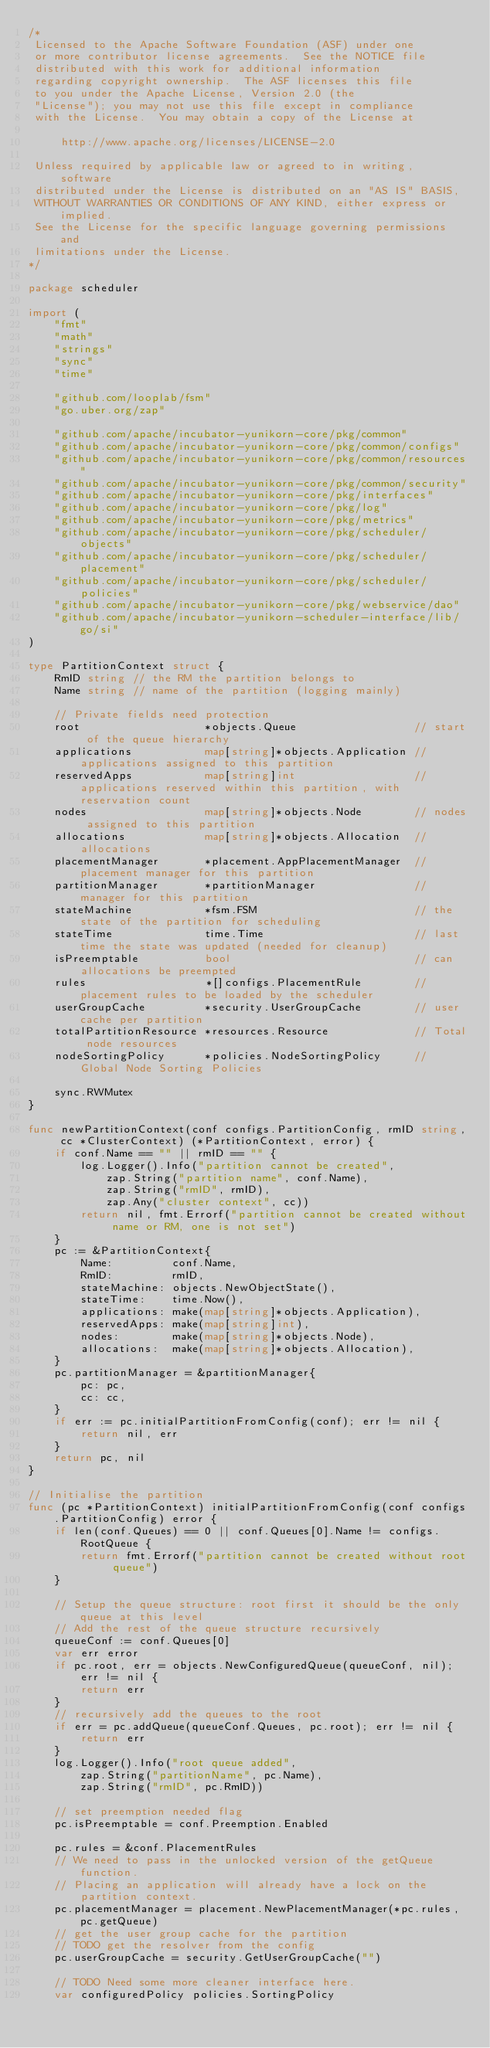Convert code to text. <code><loc_0><loc_0><loc_500><loc_500><_Go_>/*
 Licensed to the Apache Software Foundation (ASF) under one
 or more contributor license agreements.  See the NOTICE file
 distributed with this work for additional information
 regarding copyright ownership.  The ASF licenses this file
 to you under the Apache License, Version 2.0 (the
 "License"); you may not use this file except in compliance
 with the License.  You may obtain a copy of the License at

     http://www.apache.org/licenses/LICENSE-2.0

 Unless required by applicable law or agreed to in writing, software
 distributed under the License is distributed on an "AS IS" BASIS,
 WITHOUT WARRANTIES OR CONDITIONS OF ANY KIND, either express or implied.
 See the License for the specific language governing permissions and
 limitations under the License.
*/

package scheduler

import (
	"fmt"
	"math"
	"strings"
	"sync"
	"time"

	"github.com/looplab/fsm"
	"go.uber.org/zap"

	"github.com/apache/incubator-yunikorn-core/pkg/common"
	"github.com/apache/incubator-yunikorn-core/pkg/common/configs"
	"github.com/apache/incubator-yunikorn-core/pkg/common/resources"
	"github.com/apache/incubator-yunikorn-core/pkg/common/security"
	"github.com/apache/incubator-yunikorn-core/pkg/interfaces"
	"github.com/apache/incubator-yunikorn-core/pkg/log"
	"github.com/apache/incubator-yunikorn-core/pkg/metrics"
	"github.com/apache/incubator-yunikorn-core/pkg/scheduler/objects"
	"github.com/apache/incubator-yunikorn-core/pkg/scheduler/placement"
	"github.com/apache/incubator-yunikorn-core/pkg/scheduler/policies"
	"github.com/apache/incubator-yunikorn-core/pkg/webservice/dao"
	"github.com/apache/incubator-yunikorn-scheduler-interface/lib/go/si"
)

type PartitionContext struct {
	RmID string // the RM the partition belongs to
	Name string // name of the partition (logging mainly)

	// Private fields need protection
	root                   *objects.Queue                  // start of the queue hierarchy
	applications           map[string]*objects.Application // applications assigned to this partition
	reservedApps           map[string]int                  // applications reserved within this partition, with reservation count
	nodes                  map[string]*objects.Node        // nodes assigned to this partition
	allocations            map[string]*objects.Allocation  // allocations
	placementManager       *placement.AppPlacementManager  // placement manager for this partition
	partitionManager       *partitionManager               // manager for this partition
	stateMachine           *fsm.FSM                        // the state of the partition for scheduling
	stateTime              time.Time                       // last time the state was updated (needed for cleanup)
	isPreemptable          bool                            // can allocations be preempted
	rules                  *[]configs.PlacementRule        // placement rules to be loaded by the scheduler
	userGroupCache         *security.UserGroupCache        // user cache per partition
	totalPartitionResource *resources.Resource             // Total node resources
	nodeSortingPolicy      *policies.NodeSortingPolicy     // Global Node Sorting Policies

	sync.RWMutex
}

func newPartitionContext(conf configs.PartitionConfig, rmID string, cc *ClusterContext) (*PartitionContext, error) {
	if conf.Name == "" || rmID == "" {
		log.Logger().Info("partition cannot be created",
			zap.String("partition name", conf.Name),
			zap.String("rmID", rmID),
			zap.Any("cluster context", cc))
		return nil, fmt.Errorf("partition cannot be created without name or RM, one is not set")
	}
	pc := &PartitionContext{
		Name:         conf.Name,
		RmID:         rmID,
		stateMachine: objects.NewObjectState(),
		stateTime:    time.Now(),
		applications: make(map[string]*objects.Application),
		reservedApps: make(map[string]int),
		nodes:        make(map[string]*objects.Node),
		allocations:  make(map[string]*objects.Allocation),
	}
	pc.partitionManager = &partitionManager{
		pc: pc,
		cc: cc,
	}
	if err := pc.initialPartitionFromConfig(conf); err != nil {
		return nil, err
	}
	return pc, nil
}

// Initialise the partition
func (pc *PartitionContext) initialPartitionFromConfig(conf configs.PartitionConfig) error {
	if len(conf.Queues) == 0 || conf.Queues[0].Name != configs.RootQueue {
		return fmt.Errorf("partition cannot be created without root queue")
	}

	// Setup the queue structure: root first it should be the only queue at this level
	// Add the rest of the queue structure recursively
	queueConf := conf.Queues[0]
	var err error
	if pc.root, err = objects.NewConfiguredQueue(queueConf, nil); err != nil {
		return err
	}
	// recursively add the queues to the root
	if err = pc.addQueue(queueConf.Queues, pc.root); err != nil {
		return err
	}
	log.Logger().Info("root queue added",
		zap.String("partitionName", pc.Name),
		zap.String("rmID", pc.RmID))

	// set preemption needed flag
	pc.isPreemptable = conf.Preemption.Enabled

	pc.rules = &conf.PlacementRules
	// We need to pass in the unlocked version of the getQueue function.
	// Placing an application will already have a lock on the partition context.
	pc.placementManager = placement.NewPlacementManager(*pc.rules, pc.getQueue)
	// get the user group cache for the partition
	// TODO get the resolver from the config
	pc.userGroupCache = security.GetUserGroupCache("")

	// TODO Need some more cleaner interface here.
	var configuredPolicy policies.SortingPolicy</code> 